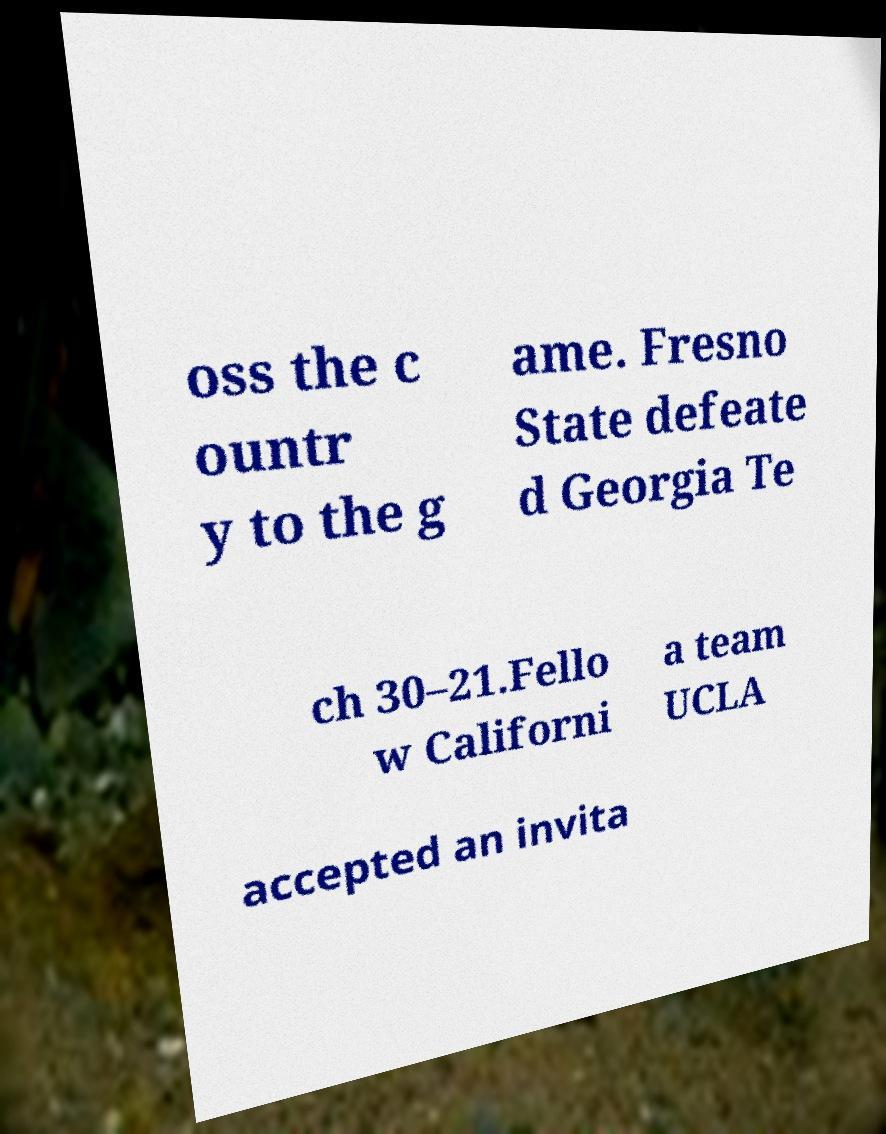Please identify and transcribe the text found in this image. oss the c ountr y to the g ame. Fresno State defeate d Georgia Te ch 30–21.Fello w Californi a team UCLA accepted an invita 